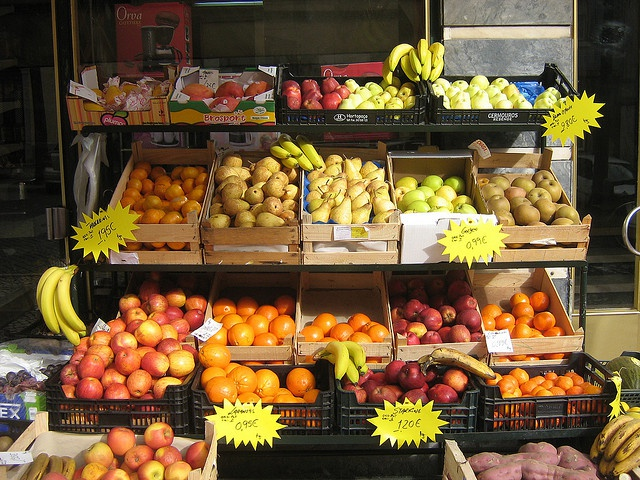Describe the objects in this image and their specific colors. I can see apple in black, red, orange, brown, and maroon tones, apple in black, maroon, brown, and salmon tones, apple in black, orange, red, and brown tones, orange in black, orange, red, and maroon tones, and apple in black, maroon, brown, and salmon tones in this image. 